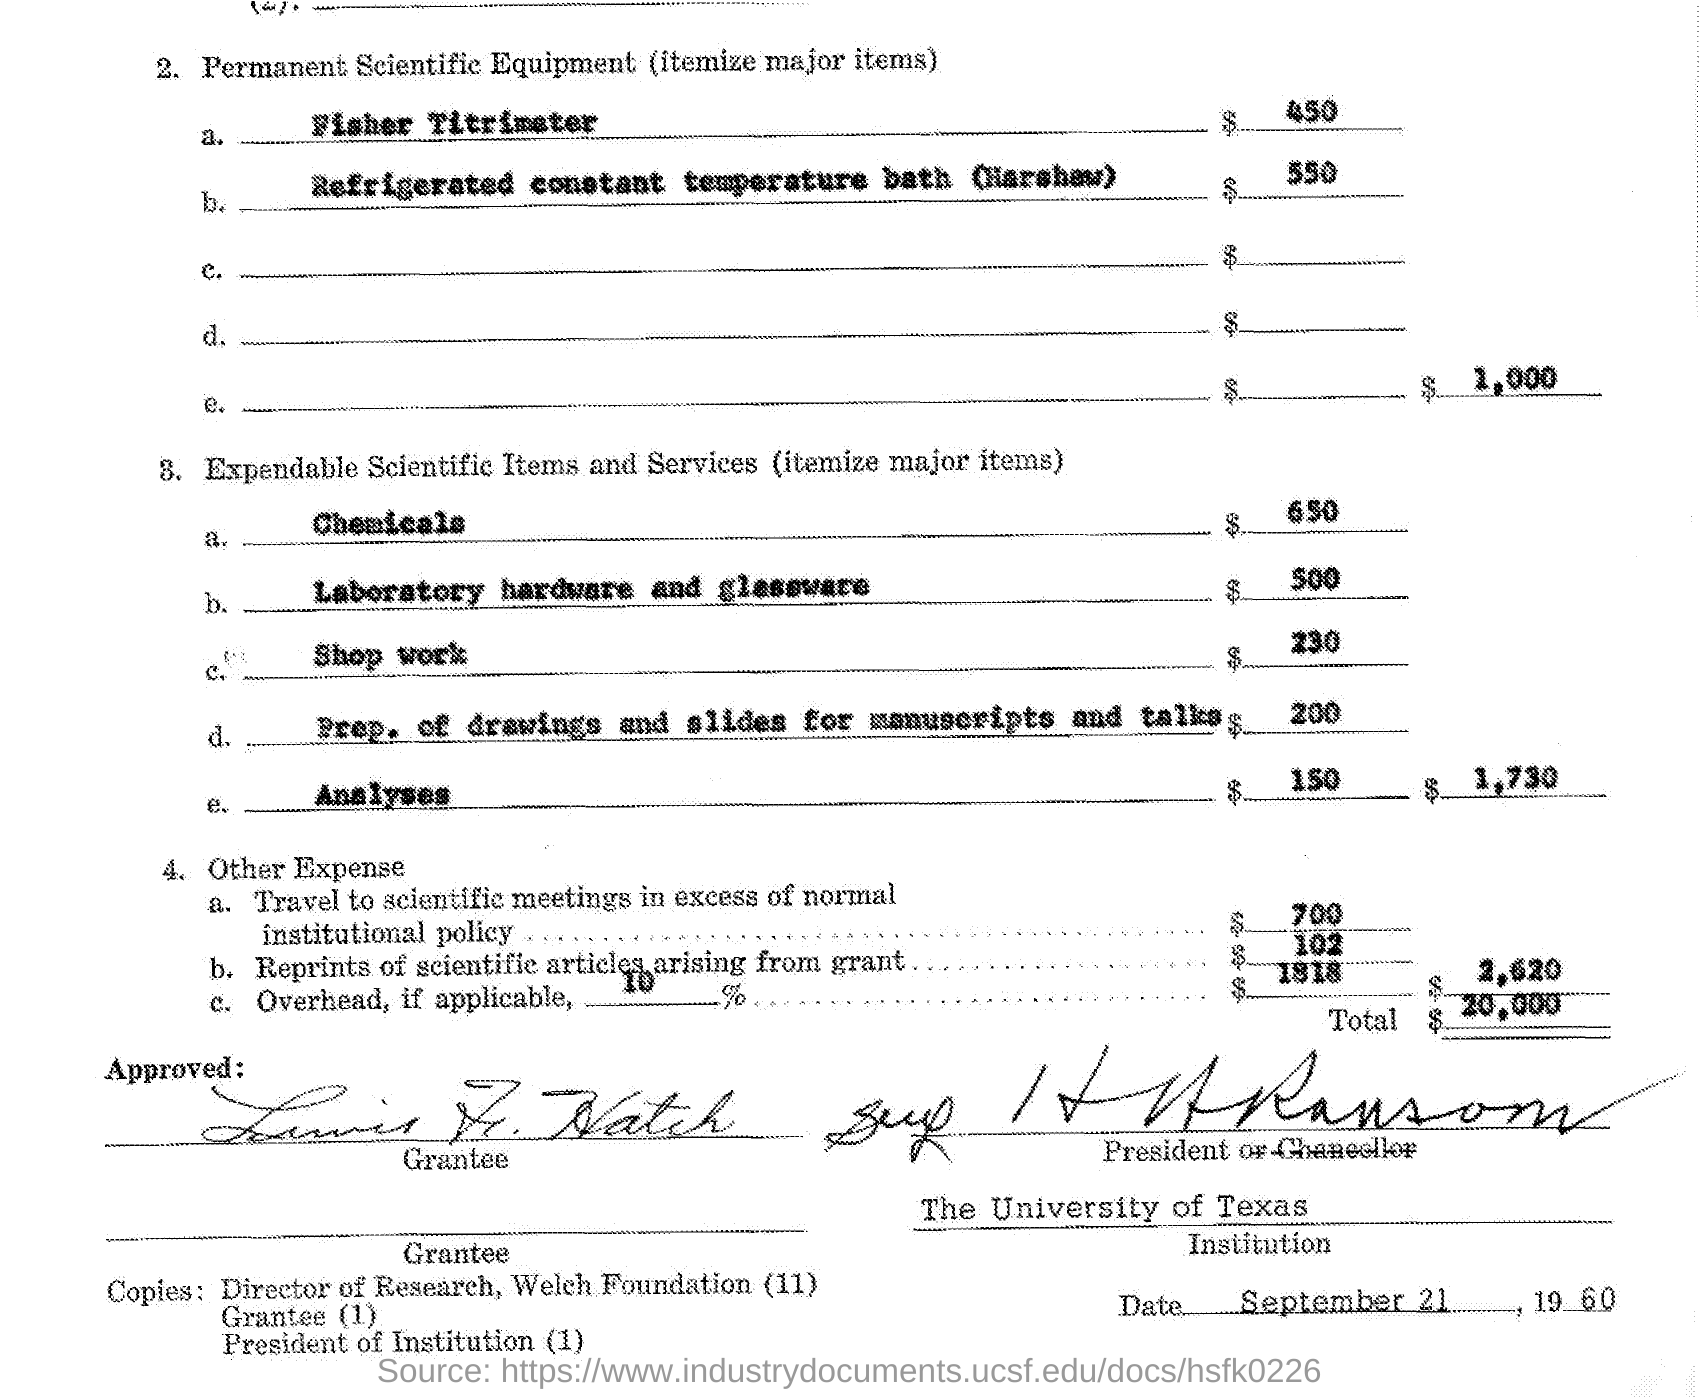Highlight a few significant elements in this photo. The total amount is $20,000. The expense for a Fisher titrimeter is $450. The expense for laboratory hardware and glassware is $500. The expense for chemicals amounts to $650. The expense for the shop work is $230. 